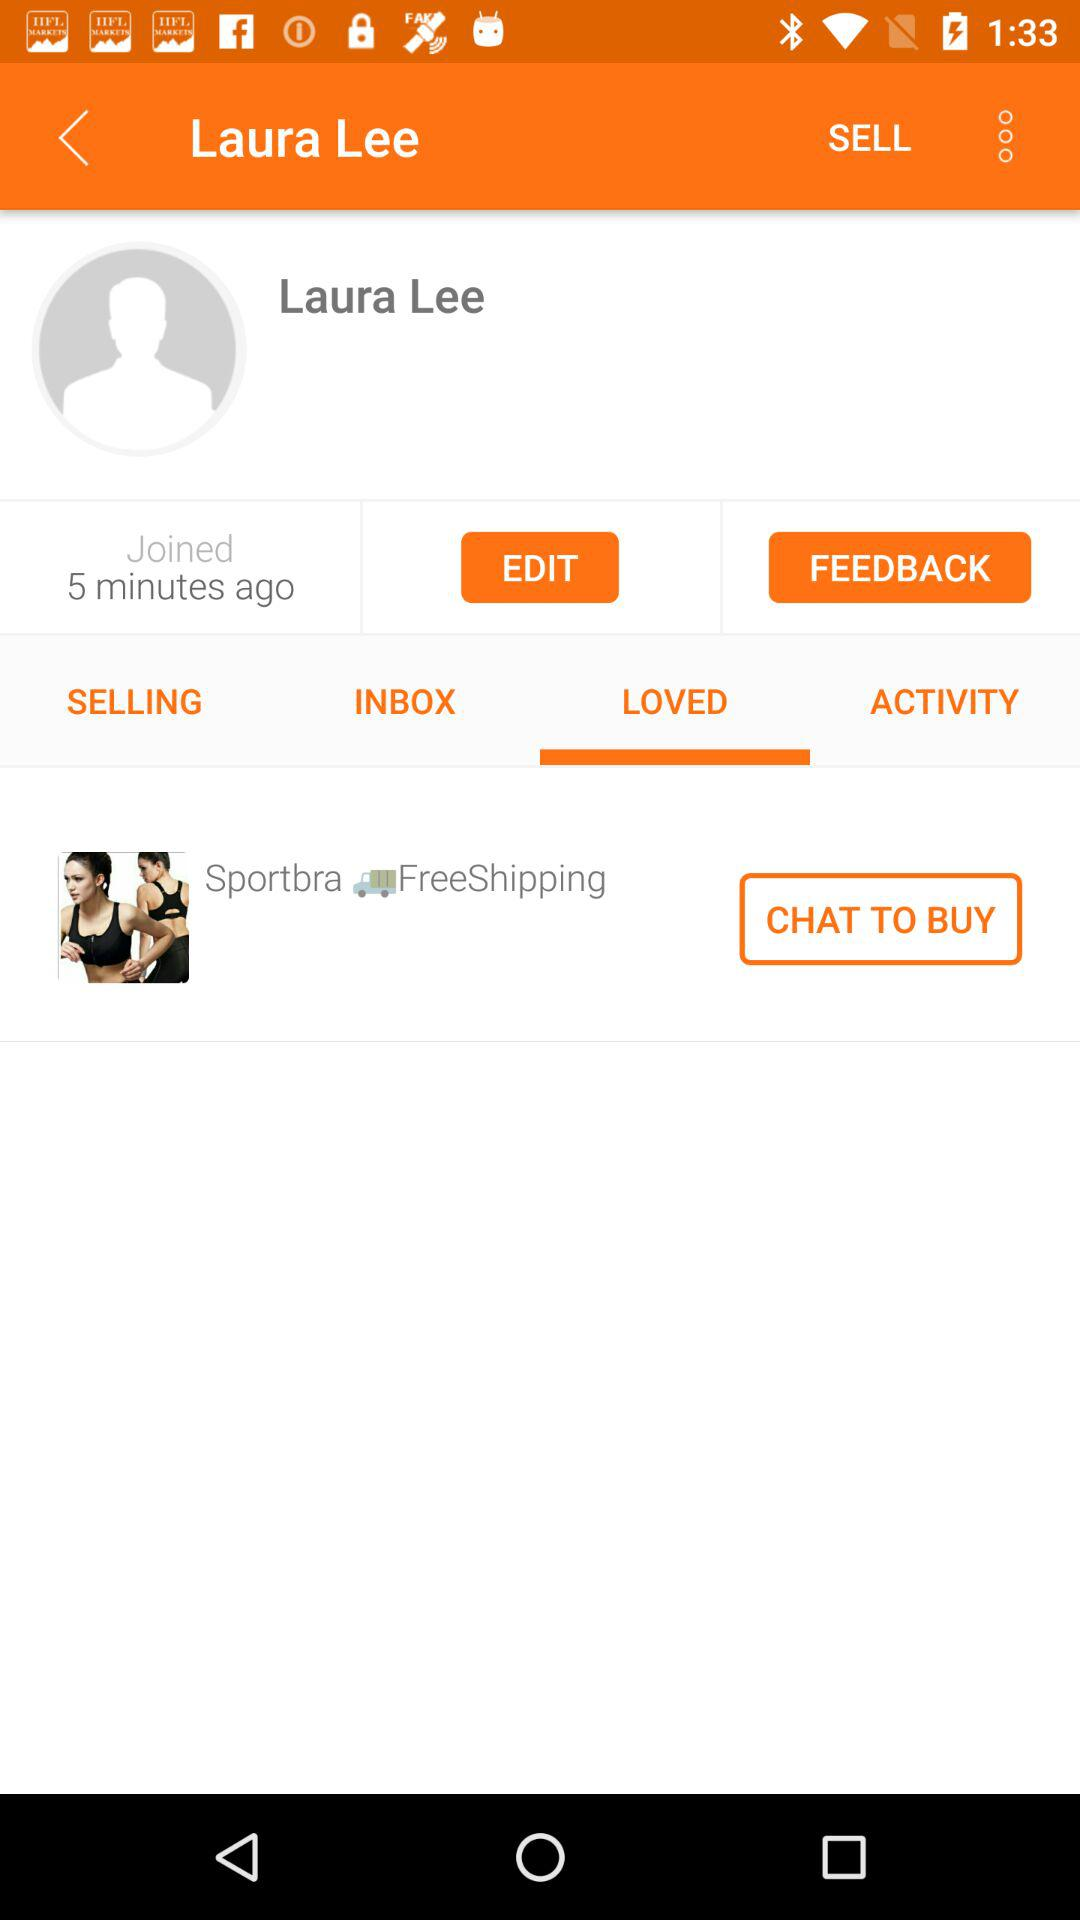How many messages are in the inbox?
When the provided information is insufficient, respond with <no answer>. <no answer> 